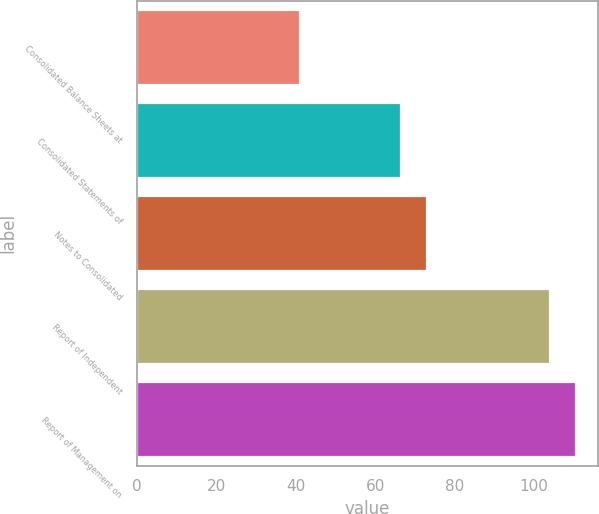<chart> <loc_0><loc_0><loc_500><loc_500><bar_chart><fcel>Consolidated Balance Sheets at<fcel>Consolidated Statements of<fcel>Notes to Consolidated<fcel>Report of Independent<fcel>Report of Management on<nl><fcel>41<fcel>66.6<fcel>73<fcel>104<fcel>110.4<nl></chart> 